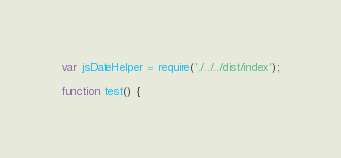<code> <loc_0><loc_0><loc_500><loc_500><_JavaScript_>
var jsDateHelper = require('./../../dist/index');

function test() {</code> 